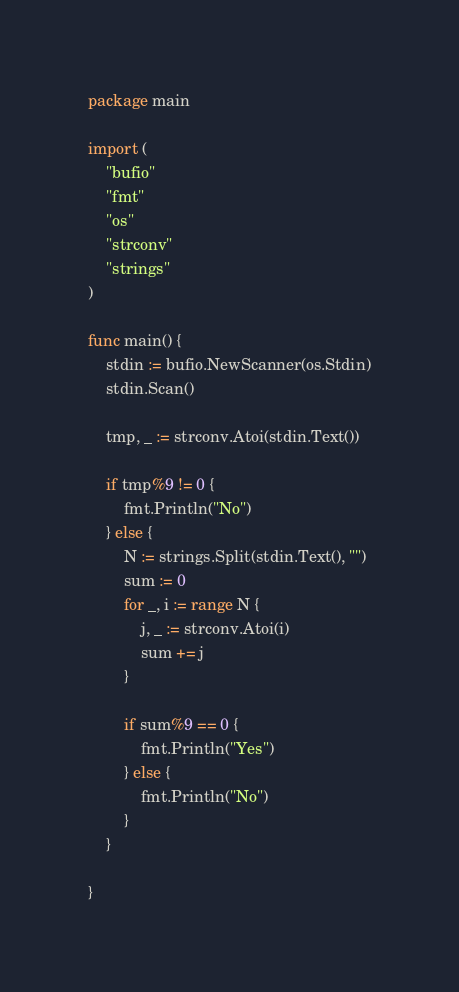Convert code to text. <code><loc_0><loc_0><loc_500><loc_500><_Go_>package main

import (
	"bufio"
	"fmt"
	"os"
	"strconv"
	"strings"
)

func main() {
	stdin := bufio.NewScanner(os.Stdin)
	stdin.Scan()

	tmp, _ := strconv.Atoi(stdin.Text())

	if tmp%9 != 0 {
		fmt.Println("No")
	} else {
		N := strings.Split(stdin.Text(), "")
		sum := 0
		for _, i := range N {
			j, _ := strconv.Atoi(i)
			sum += j
		}

		if sum%9 == 0 {
			fmt.Println("Yes")
		} else {
			fmt.Println("No")
		}
	}

}
</code> 